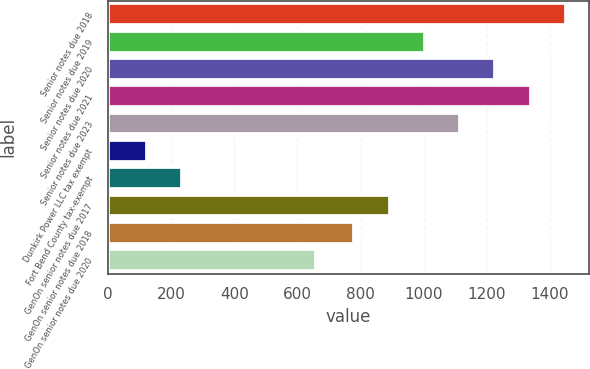<chart> <loc_0><loc_0><loc_500><loc_500><bar_chart><fcel>Senior notes due 2018<fcel>Senior notes due 2019<fcel>Senior notes due 2020<fcel>Senior notes due 2021<fcel>Senior notes due 2023<fcel>Dunkirk Power LLC tax exempt<fcel>Fort Bend County tax-exempt<fcel>GenOn senior notes due 2017<fcel>GenOn senior notes due 2018<fcel>GenOn senior notes due 2020<nl><fcel>1452<fcel>1004<fcel>1228<fcel>1340<fcel>1116<fcel>122<fcel>234<fcel>892<fcel>780<fcel>659<nl></chart> 